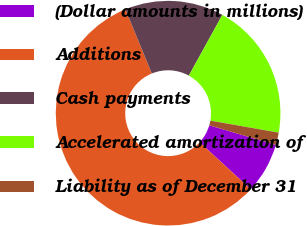<chart> <loc_0><loc_0><loc_500><loc_500><pie_chart><fcel>(Dollar amounts in millions)<fcel>Additions<fcel>Cash payments<fcel>Accelerated amortization of<fcel>Liability as of December 31<nl><fcel>7.3%<fcel>56.94%<fcel>14.23%<fcel>19.75%<fcel>1.78%<nl></chart> 